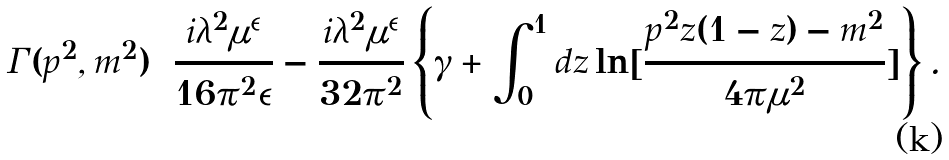<formula> <loc_0><loc_0><loc_500><loc_500>\Gamma ( p ^ { 2 } , m ^ { 2 } ) = \frac { i \lambda ^ { 2 } \mu ^ { \epsilon } } { 1 6 \pi ^ { 2 } \epsilon } - \frac { i \lambda ^ { 2 } \mu ^ { \epsilon } } { 3 2 \pi ^ { 2 } } \left \{ \gamma + \int _ { 0 } ^ { 1 } d z \ln [ \frac { p ^ { 2 } z ( 1 - z ) - m ^ { 2 } } { 4 \pi \mu ^ { 2 } } ] \right \} .</formula> 